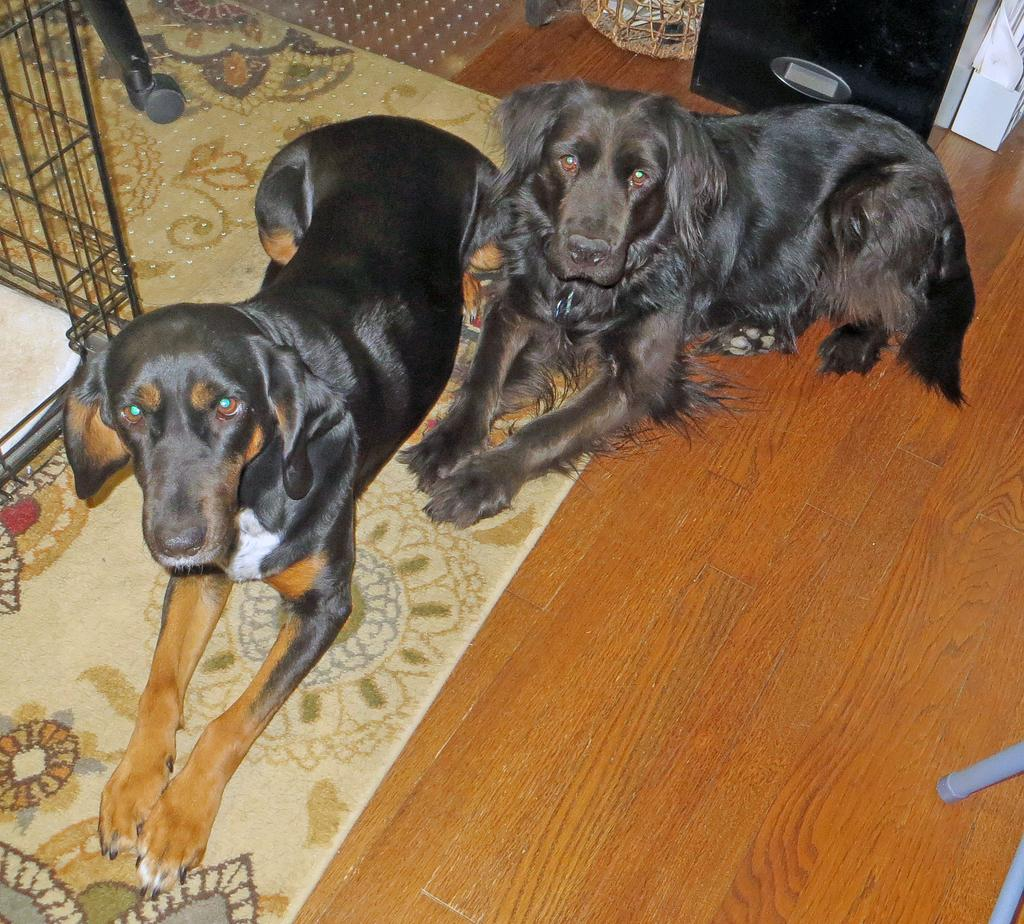What animals are sitting on the floor in the image? There are two dogs sitting on the floor in the image. What can be seen on the left side of the image? There is a cage on the left side of the image. What is located in the right top area of the image? There is a basket in the right top area of the image. What is on the floor besides the dogs? There are objects on the floor in the image. What type of furniture is in the right bottom area of the image? There is a chair in the right bottom area of the image. How many borders are visible in the image? There are no borders visible in the image; it is a photograph or illustration without any borders. 